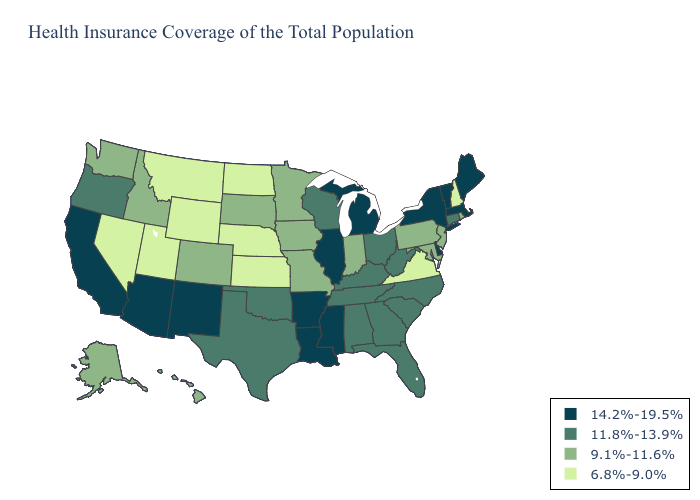Does New Hampshire have the lowest value in the Northeast?
Short answer required. Yes. What is the value of Montana?
Keep it brief. 6.8%-9.0%. What is the highest value in states that border Wisconsin?
Give a very brief answer. 14.2%-19.5%. Does Alabama have the lowest value in the USA?
Short answer required. No. Name the states that have a value in the range 14.2%-19.5%?
Answer briefly. Arizona, Arkansas, California, Delaware, Illinois, Louisiana, Maine, Massachusetts, Michigan, Mississippi, New Mexico, New York, Vermont. What is the value of North Carolina?
Give a very brief answer. 11.8%-13.9%. What is the lowest value in the USA?
Keep it brief. 6.8%-9.0%. Name the states that have a value in the range 11.8%-13.9%?
Answer briefly. Alabama, Connecticut, Florida, Georgia, Kentucky, North Carolina, Ohio, Oklahoma, Oregon, South Carolina, Tennessee, Texas, West Virginia, Wisconsin. Does New Jersey have the lowest value in the Northeast?
Concise answer only. No. Name the states that have a value in the range 11.8%-13.9%?
Keep it brief. Alabama, Connecticut, Florida, Georgia, Kentucky, North Carolina, Ohio, Oklahoma, Oregon, South Carolina, Tennessee, Texas, West Virginia, Wisconsin. Among the states that border Kansas , does Missouri have the lowest value?
Keep it brief. No. Does Louisiana have the highest value in the USA?
Give a very brief answer. Yes. What is the value of West Virginia?
Give a very brief answer. 11.8%-13.9%. Does the map have missing data?
Keep it brief. No. 